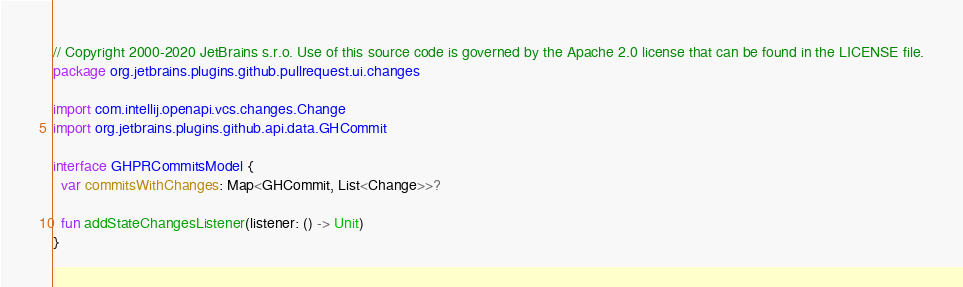Convert code to text. <code><loc_0><loc_0><loc_500><loc_500><_Kotlin_>// Copyright 2000-2020 JetBrains s.r.o. Use of this source code is governed by the Apache 2.0 license that can be found in the LICENSE file.
package org.jetbrains.plugins.github.pullrequest.ui.changes

import com.intellij.openapi.vcs.changes.Change
import org.jetbrains.plugins.github.api.data.GHCommit

interface GHPRCommitsModel {
  var commitsWithChanges: Map<GHCommit, List<Change>>?

  fun addStateChangesListener(listener: () -> Unit)
}
</code> 